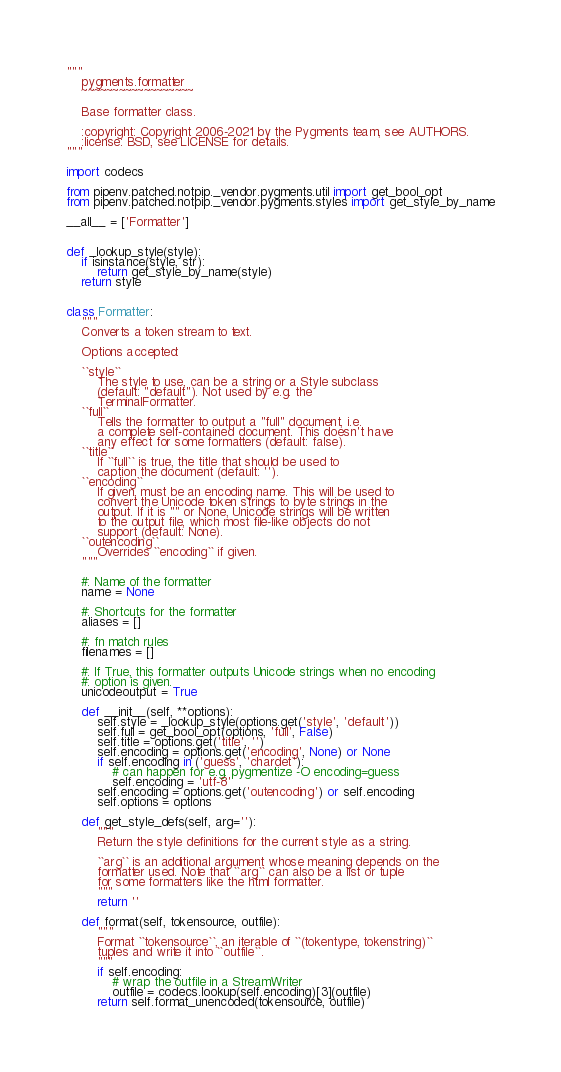<code> <loc_0><loc_0><loc_500><loc_500><_Python_>"""
    pygments.formatter
    ~~~~~~~~~~~~~~~~~~

    Base formatter class.

    :copyright: Copyright 2006-2021 by the Pygments team, see AUTHORS.
    :license: BSD, see LICENSE for details.
"""

import codecs

from pipenv.patched.notpip._vendor.pygments.util import get_bool_opt
from pipenv.patched.notpip._vendor.pygments.styles import get_style_by_name

__all__ = ['Formatter']


def _lookup_style(style):
    if isinstance(style, str):
        return get_style_by_name(style)
    return style


class Formatter:
    """
    Converts a token stream to text.

    Options accepted:

    ``style``
        The style to use, can be a string or a Style subclass
        (default: "default"). Not used by e.g. the
        TerminalFormatter.
    ``full``
        Tells the formatter to output a "full" document, i.e.
        a complete self-contained document. This doesn't have
        any effect for some formatters (default: false).
    ``title``
        If ``full`` is true, the title that should be used to
        caption the document (default: '').
    ``encoding``
        If given, must be an encoding name. This will be used to
        convert the Unicode token strings to byte strings in the
        output. If it is "" or None, Unicode strings will be written
        to the output file, which most file-like objects do not
        support (default: None).
    ``outencoding``
        Overrides ``encoding`` if given.
    """

    #: Name of the formatter
    name = None

    #: Shortcuts for the formatter
    aliases = []

    #: fn match rules
    filenames = []

    #: If True, this formatter outputs Unicode strings when no encoding
    #: option is given.
    unicodeoutput = True

    def __init__(self, **options):
        self.style = _lookup_style(options.get('style', 'default'))
        self.full = get_bool_opt(options, 'full', False)
        self.title = options.get('title', '')
        self.encoding = options.get('encoding', None) or None
        if self.encoding in ('guess', 'chardet'):
            # can happen for e.g. pygmentize -O encoding=guess
            self.encoding = 'utf-8'
        self.encoding = options.get('outencoding') or self.encoding
        self.options = options

    def get_style_defs(self, arg=''):
        """
        Return the style definitions for the current style as a string.

        ``arg`` is an additional argument whose meaning depends on the
        formatter used. Note that ``arg`` can also be a list or tuple
        for some formatters like the html formatter.
        """
        return ''

    def format(self, tokensource, outfile):
        """
        Format ``tokensource``, an iterable of ``(tokentype, tokenstring)``
        tuples and write it into ``outfile``.
        """
        if self.encoding:
            # wrap the outfile in a StreamWriter
            outfile = codecs.lookup(self.encoding)[3](outfile)
        return self.format_unencoded(tokensource, outfile)
</code> 